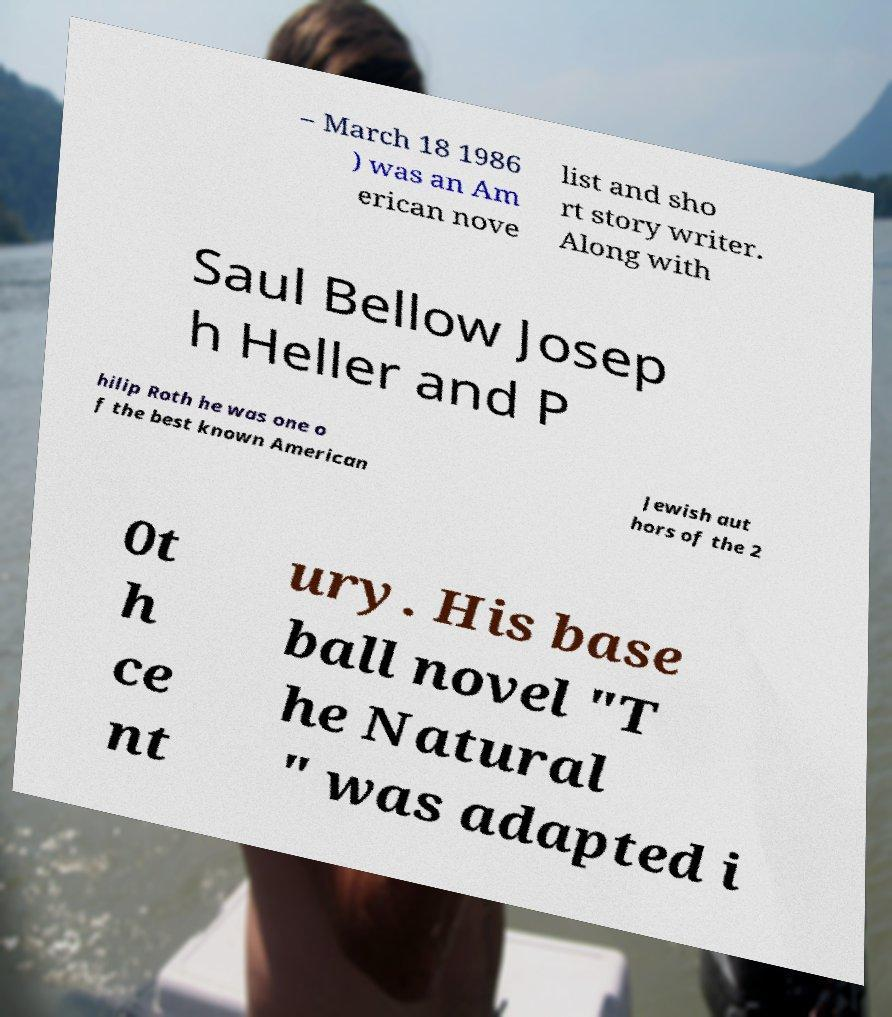Could you extract and type out the text from this image? – March 18 1986 ) was an Am erican nove list and sho rt story writer. Along with Saul Bellow Josep h Heller and P hilip Roth he was one o f the best known American Jewish aut hors of the 2 0t h ce nt ury. His base ball novel "T he Natural " was adapted i 